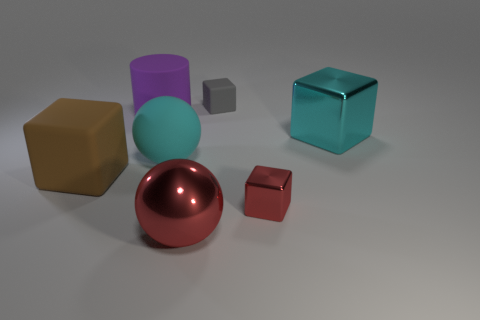There is a red ball that is the same size as the brown matte block; what is its material?
Make the answer very short. Metal. There is a metallic cube that is in front of the big cyan metal object; how big is it?
Offer a terse response. Small. There is a cube left of the gray matte object; is it the same size as the red object behind the red metal sphere?
Keep it short and to the point. No. What number of small things have the same material as the red block?
Ensure brevity in your answer.  0. The big matte sphere is what color?
Your answer should be compact. Cyan. There is a small red metal object; are there any large things to the right of it?
Offer a very short reply. Yes. Is the large rubber sphere the same color as the big shiny block?
Offer a terse response. Yes. What number of tiny objects have the same color as the matte cylinder?
Provide a succinct answer. 0. There is a rubber thing to the right of the sphere behind the metal sphere; what is its size?
Ensure brevity in your answer.  Small. What is the shape of the big purple rubber object?
Keep it short and to the point. Cylinder. 